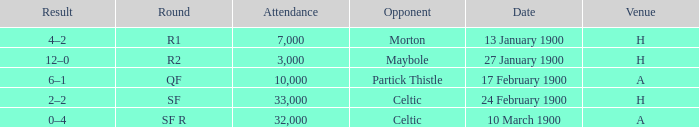Who played against in venue a on 17 february 1900? Partick Thistle. 